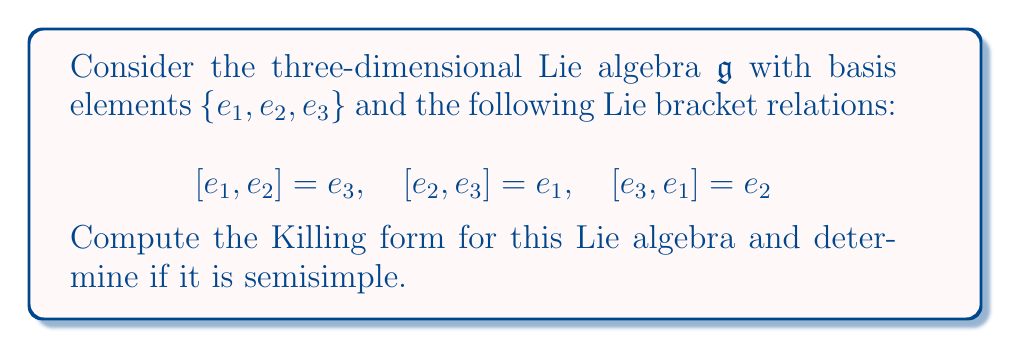Show me your answer to this math problem. To solve this problem, we'll follow these steps:

1) First, we need to compute the adjoint representations of each basis element.
2) Then, we'll calculate the Killing form using these adjoint representations.
3) Finally, we'll determine if the Lie algebra is semisimple based on the Killing form.

Step 1: Computing the adjoint representations

For each basis element $e_i$, we need to find $ad(e_i)$ such that $ad(e_i)(e_j) = [e_i, e_j]$.

$ad(e_1)$:
$ad(e_1)(e_1) = 0$
$ad(e_1)(e_2) = e_3$
$ad(e_1)(e_3) = -e_2$

So, $ad(e_1) = \begin{pmatrix} 0 & 0 & 0 \\ 0 & 0 & -1 \\ 0 & 1 & 0 \end{pmatrix}$

Similarly,
$ad(e_2) = \begin{pmatrix} 0 & 0 & 1 \\ 0 & 0 & 0 \\ -1 & 0 & 0 \end{pmatrix}$

$ad(e_3) = \begin{pmatrix} 0 & -1 & 0 \\ 1 & 0 & 0 \\ 0 & 0 & 0 \end{pmatrix}$

Step 2: Calculating the Killing form

The Killing form $K(x,y)$ is defined as $K(x,y) = tr(ad(x)ad(y))$, where $tr$ denotes the trace of a matrix.

For basis elements:
$K(e_1,e_1) = tr(ad(e_1)ad(e_1)) = tr(\begin{pmatrix} 0 & 0 & 0 \\ 0 & -1 & 0 \\ 0 & 0 & -1 \end{pmatrix}) = -2$

Similarly,
$K(e_2,e_2) = K(e_3,e_3) = -2$
$K(e_1,e_2) = K(e_2,e_1) = K(e_1,e_3) = K(e_3,e_1) = K(e_2,e_3) = K(e_3,e_2) = 0$

Therefore, the Killing form matrix is:

$$K = \begin{pmatrix} -2 & 0 & 0 \\ 0 & -2 & 0 \\ 0 & 0 & -2 \end{pmatrix}$$

Step 3: Determining if the Lie algebra is semisimple

A Lie algebra is semisimple if and only if its Killing form is non-degenerate (i.e., has non-zero determinant).

$det(K) = (-2)^3 = -8 \neq 0$

Since the determinant is non-zero, the Killing form is non-degenerate, and therefore the Lie algebra is semisimple.
Answer: The Killing form for the given Lie algebra is $K = \begin{pmatrix} -2 & 0 & 0 \\ 0 & -2 & 0 \\ 0 & 0 & -2 \end{pmatrix}$. The Lie algebra is semisimple because the Killing form is non-degenerate (its determinant is -8, which is non-zero). 